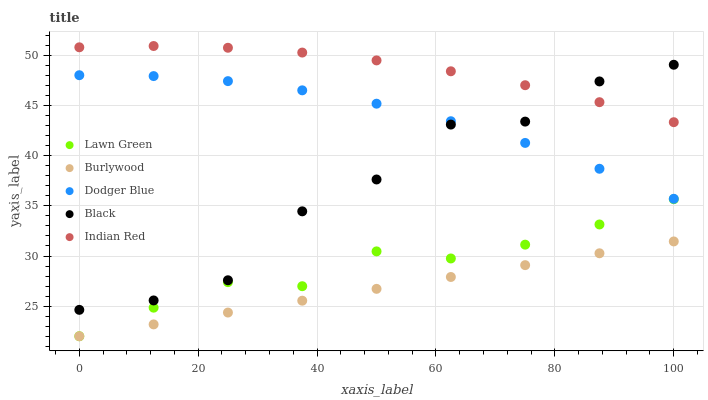Does Burlywood have the minimum area under the curve?
Answer yes or no. Yes. Does Indian Red have the maximum area under the curve?
Answer yes or no. Yes. Does Lawn Green have the minimum area under the curve?
Answer yes or no. No. Does Lawn Green have the maximum area under the curve?
Answer yes or no. No. Is Burlywood the smoothest?
Answer yes or no. Yes. Is Black the roughest?
Answer yes or no. Yes. Is Lawn Green the smoothest?
Answer yes or no. No. Is Lawn Green the roughest?
Answer yes or no. No. Does Burlywood have the lowest value?
Answer yes or no. Yes. Does Dodger Blue have the lowest value?
Answer yes or no. No. Does Indian Red have the highest value?
Answer yes or no. Yes. Does Lawn Green have the highest value?
Answer yes or no. No. Is Lawn Green less than Dodger Blue?
Answer yes or no. Yes. Is Dodger Blue greater than Lawn Green?
Answer yes or no. Yes. Does Black intersect Dodger Blue?
Answer yes or no. Yes. Is Black less than Dodger Blue?
Answer yes or no. No. Is Black greater than Dodger Blue?
Answer yes or no. No. Does Lawn Green intersect Dodger Blue?
Answer yes or no. No. 